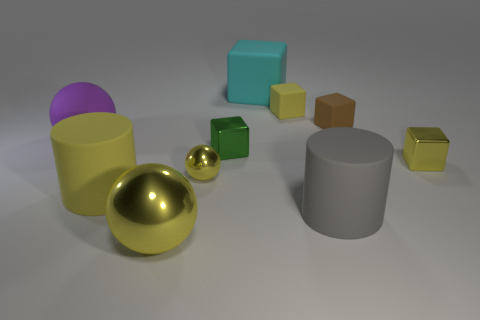Subtract all large yellow spheres. How many spheres are left? 2 Subtract all yellow balls. How many balls are left? 1 Subtract 1 cylinders. How many cylinders are left? 1 Subtract all cylinders. How many objects are left? 8 Subtract all big spheres. Subtract all brown rubber objects. How many objects are left? 7 Add 9 big cyan things. How many big cyan things are left? 10 Add 8 cyan rubber things. How many cyan rubber things exist? 9 Subtract 1 yellow cylinders. How many objects are left? 9 Subtract all gray cylinders. Subtract all cyan balls. How many cylinders are left? 1 Subtract all yellow cubes. How many yellow balls are left? 2 